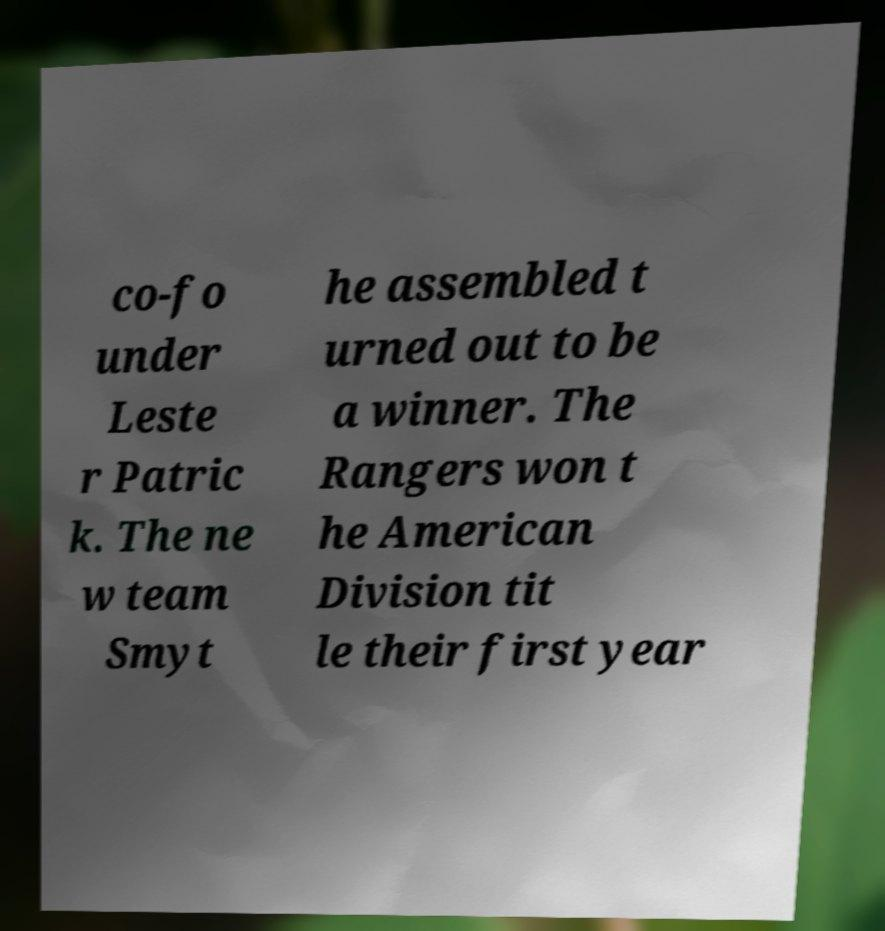I need the written content from this picture converted into text. Can you do that? co-fo under Leste r Patric k. The ne w team Smyt he assembled t urned out to be a winner. The Rangers won t he American Division tit le their first year 